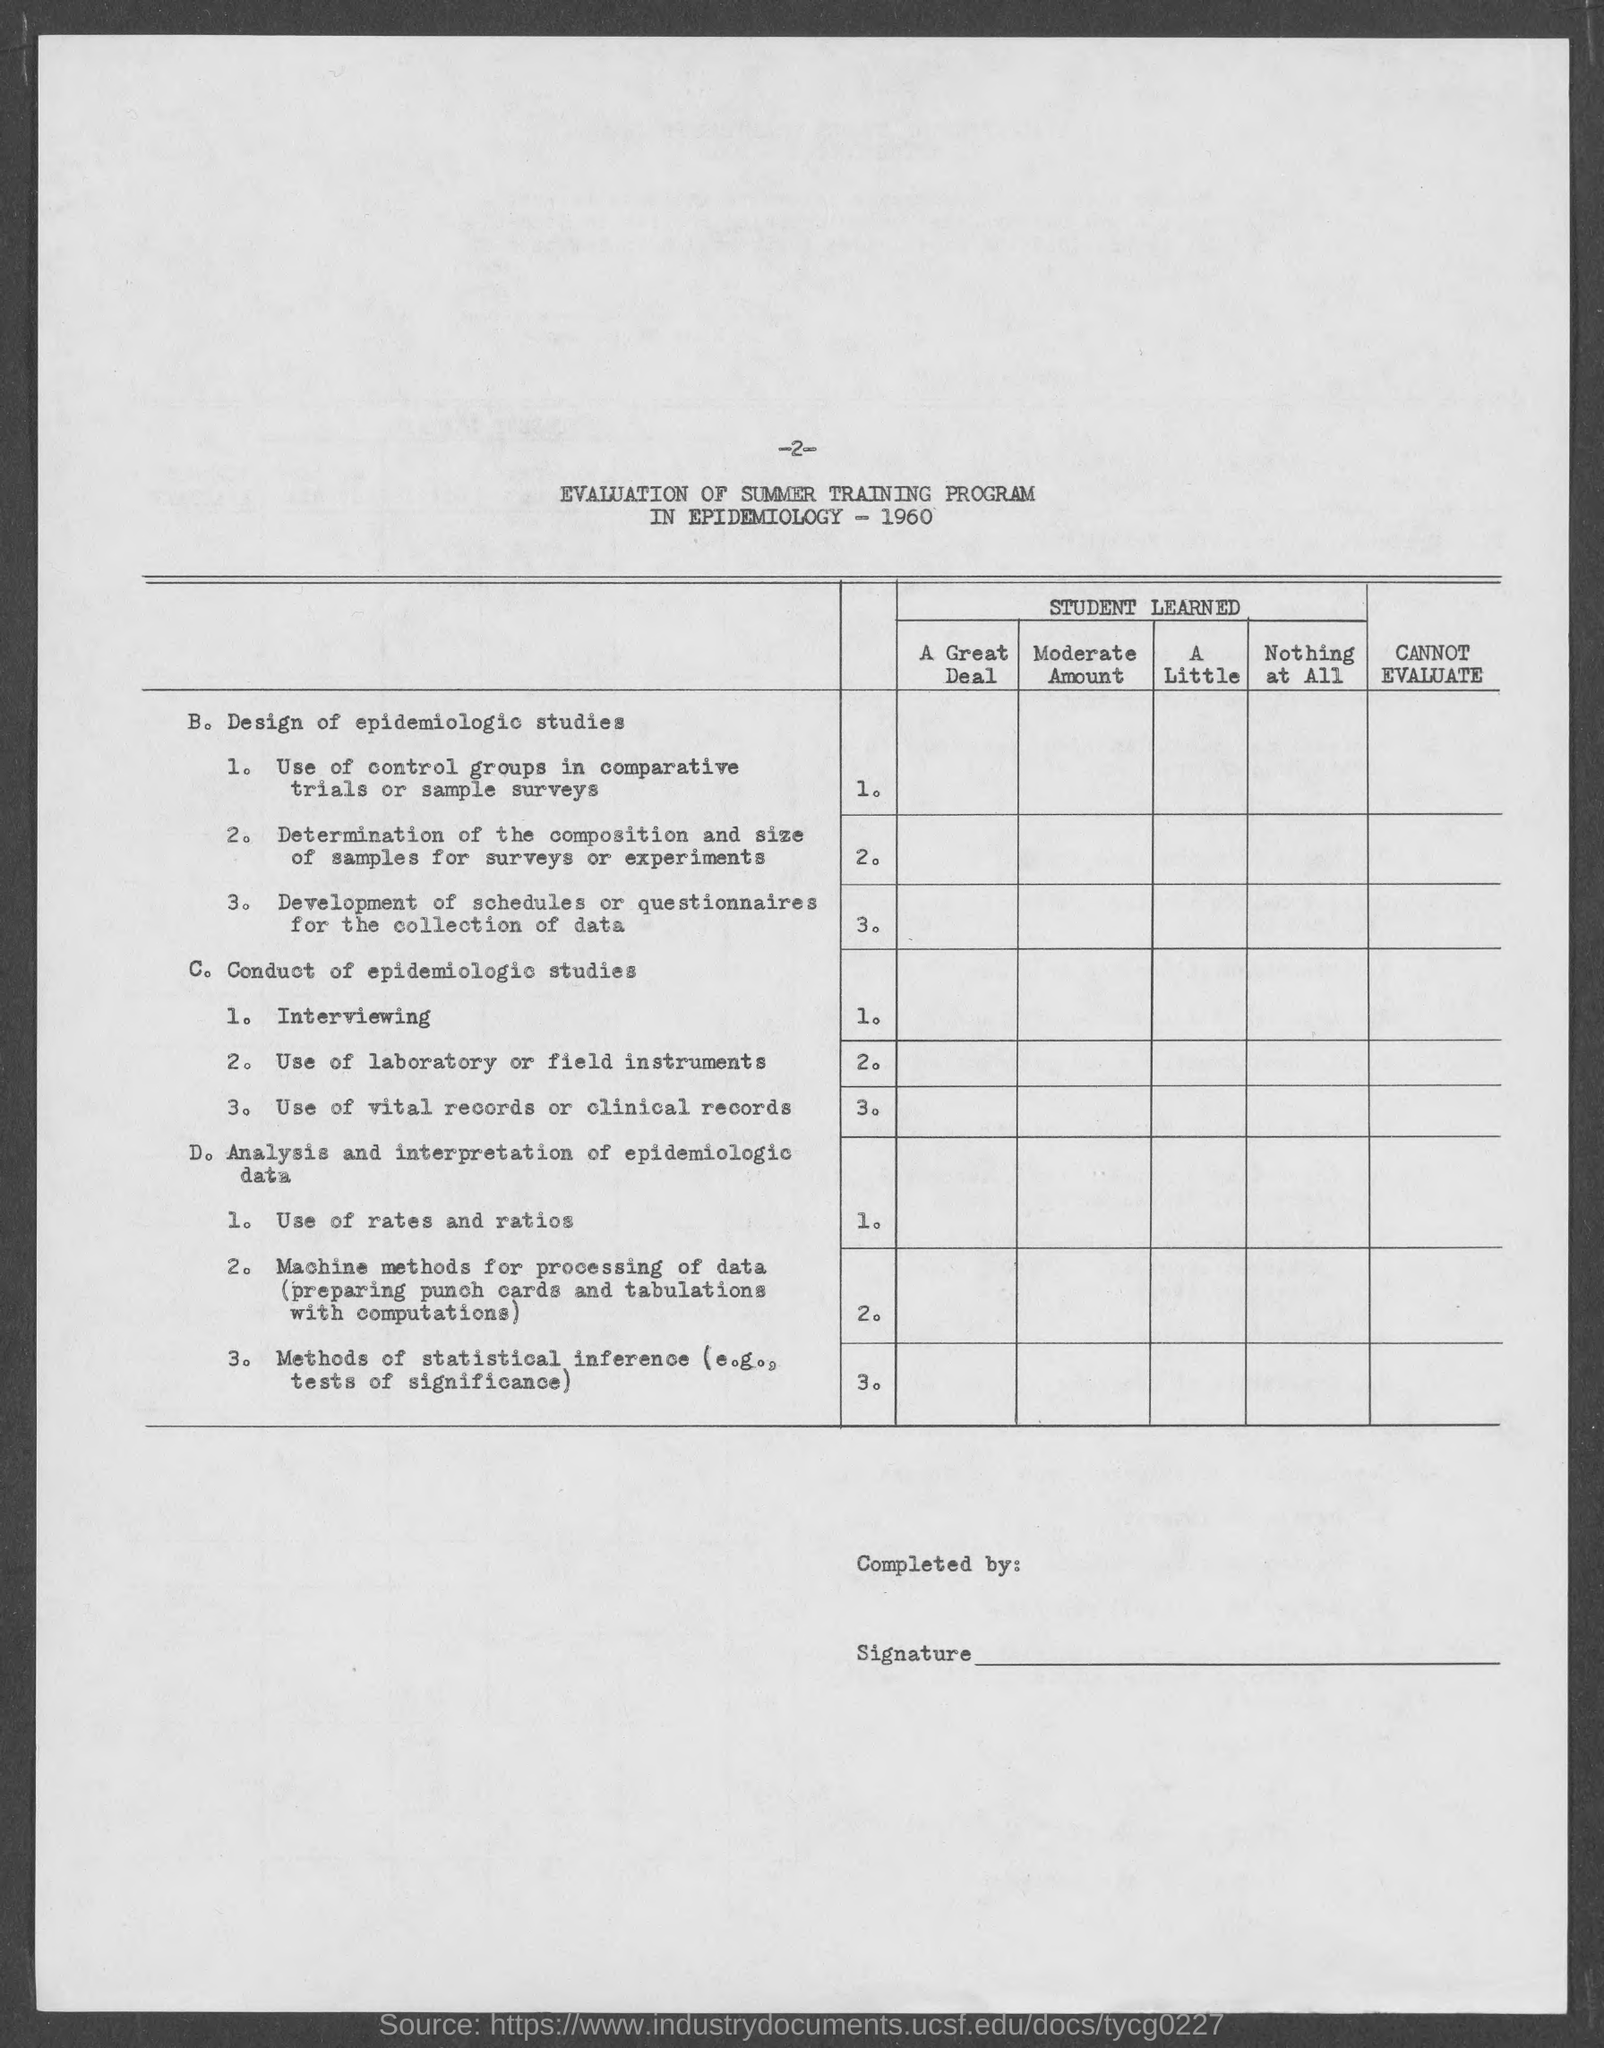Draw attention to some important aspects in this diagram. The page number mentioned in this document is -2-. 